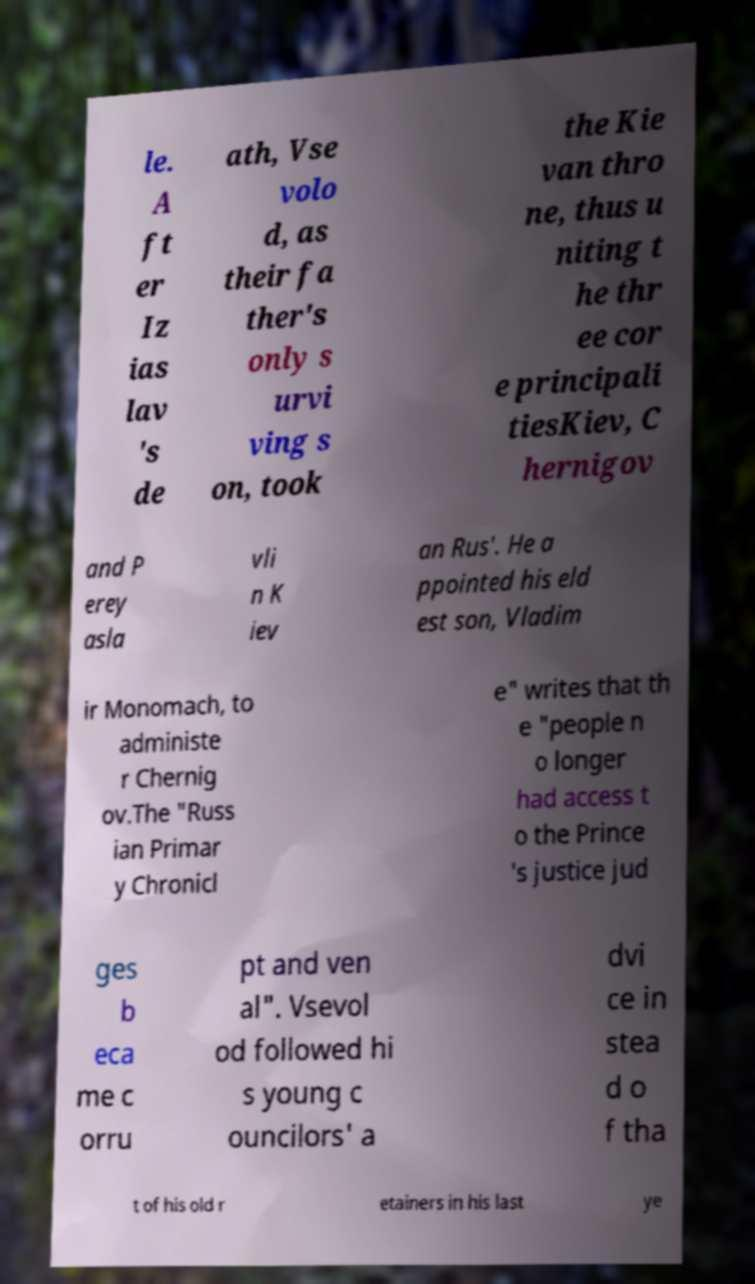Please identify and transcribe the text found in this image. le. A ft er Iz ias lav 's de ath, Vse volo d, as their fa ther's only s urvi ving s on, took the Kie van thro ne, thus u niting t he thr ee cor e principali tiesKiev, C hernigov and P erey asla vli n K iev an Rus'. He a ppointed his eld est son, Vladim ir Monomach, to administe r Chernig ov.The "Russ ian Primar y Chronicl e" writes that th e "people n o longer had access t o the Prince 's justice jud ges b eca me c orru pt and ven al". Vsevol od followed hi s young c ouncilors' a dvi ce in stea d o f tha t of his old r etainers in his last ye 